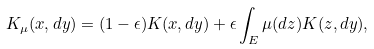<formula> <loc_0><loc_0><loc_500><loc_500>K _ { \mu } ( x , d y ) = ( 1 - \epsilon ) K ( x , d y ) + \epsilon \int _ { E } \mu ( d z ) K ( z , d y ) ,</formula> 